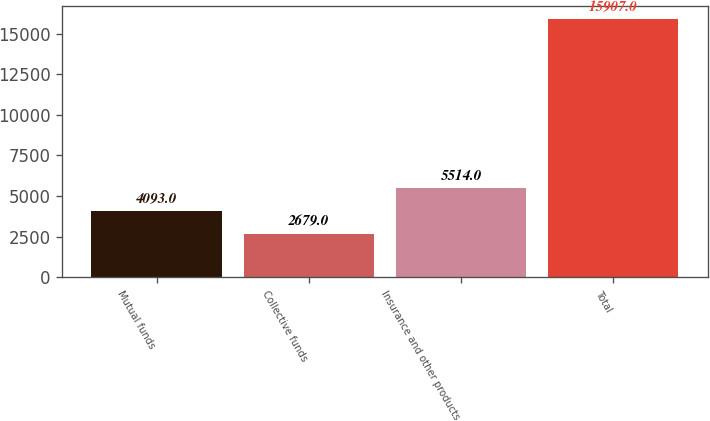<chart> <loc_0><loc_0><loc_500><loc_500><bar_chart><fcel>Mutual funds<fcel>Collective funds<fcel>Insurance and other products<fcel>Total<nl><fcel>4093<fcel>2679<fcel>5514<fcel>15907<nl></chart> 